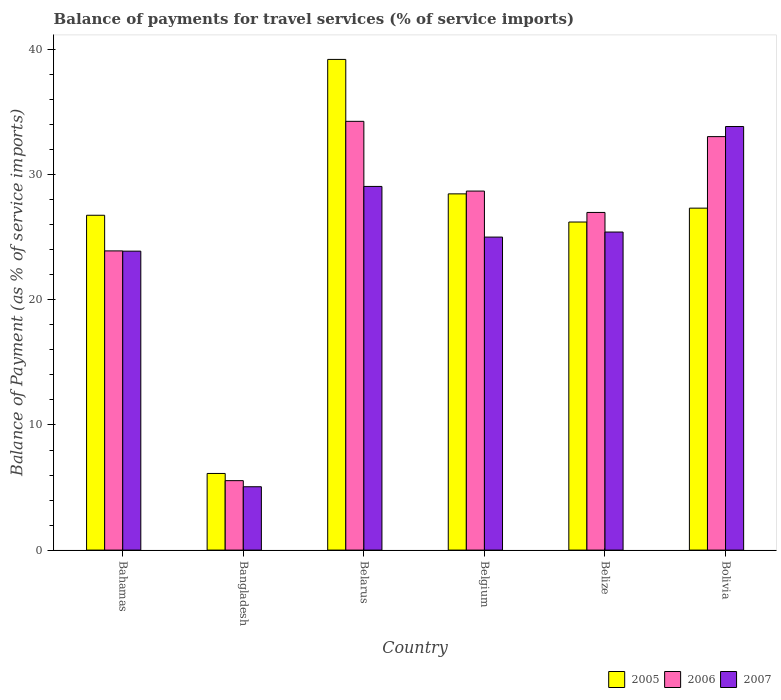How many different coloured bars are there?
Keep it short and to the point. 3. Are the number of bars per tick equal to the number of legend labels?
Give a very brief answer. Yes. How many bars are there on the 3rd tick from the left?
Keep it short and to the point. 3. How many bars are there on the 6th tick from the right?
Make the answer very short. 3. What is the label of the 5th group of bars from the left?
Make the answer very short. Belize. What is the balance of payments for travel services in 2006 in Bolivia?
Your response must be concise. 33.05. Across all countries, what is the maximum balance of payments for travel services in 2006?
Your answer should be compact. 34.27. Across all countries, what is the minimum balance of payments for travel services in 2007?
Give a very brief answer. 5.06. In which country was the balance of payments for travel services in 2005 maximum?
Ensure brevity in your answer.  Belarus. In which country was the balance of payments for travel services in 2006 minimum?
Give a very brief answer. Bangladesh. What is the total balance of payments for travel services in 2007 in the graph?
Offer a very short reply. 142.32. What is the difference between the balance of payments for travel services in 2006 in Belarus and that in Belgium?
Offer a very short reply. 5.57. What is the difference between the balance of payments for travel services in 2006 in Belize and the balance of payments for travel services in 2007 in Bangladesh?
Give a very brief answer. 21.92. What is the average balance of payments for travel services in 2007 per country?
Offer a terse response. 23.72. What is the difference between the balance of payments for travel services of/in 2007 and balance of payments for travel services of/in 2005 in Bolivia?
Give a very brief answer. 6.52. In how many countries, is the balance of payments for travel services in 2007 greater than 18 %?
Your answer should be compact. 5. What is the ratio of the balance of payments for travel services in 2007 in Bangladesh to that in Bolivia?
Provide a succinct answer. 0.15. Is the difference between the balance of payments for travel services in 2007 in Bahamas and Belgium greater than the difference between the balance of payments for travel services in 2005 in Bahamas and Belgium?
Keep it short and to the point. Yes. What is the difference between the highest and the second highest balance of payments for travel services in 2006?
Your response must be concise. -1.22. What is the difference between the highest and the lowest balance of payments for travel services in 2007?
Your answer should be very brief. 28.79. In how many countries, is the balance of payments for travel services in 2006 greater than the average balance of payments for travel services in 2006 taken over all countries?
Make the answer very short. 4. Is the sum of the balance of payments for travel services in 2007 in Belarus and Belgium greater than the maximum balance of payments for travel services in 2005 across all countries?
Keep it short and to the point. Yes. What does the 3rd bar from the right in Bahamas represents?
Provide a short and direct response. 2005. Is it the case that in every country, the sum of the balance of payments for travel services in 2006 and balance of payments for travel services in 2005 is greater than the balance of payments for travel services in 2007?
Offer a terse response. Yes. How many bars are there?
Your answer should be very brief. 18. How many countries are there in the graph?
Keep it short and to the point. 6. What is the difference between two consecutive major ticks on the Y-axis?
Your answer should be compact. 10. Are the values on the major ticks of Y-axis written in scientific E-notation?
Your answer should be compact. No. Does the graph contain any zero values?
Your response must be concise. No. Does the graph contain grids?
Provide a short and direct response. No. How many legend labels are there?
Provide a short and direct response. 3. How are the legend labels stacked?
Make the answer very short. Horizontal. What is the title of the graph?
Your answer should be very brief. Balance of payments for travel services (% of service imports). Does "1971" appear as one of the legend labels in the graph?
Provide a succinct answer. No. What is the label or title of the Y-axis?
Your answer should be very brief. Balance of Payment (as % of service imports). What is the Balance of Payment (as % of service imports) of 2005 in Bahamas?
Ensure brevity in your answer.  26.76. What is the Balance of Payment (as % of service imports) in 2006 in Bahamas?
Give a very brief answer. 23.92. What is the Balance of Payment (as % of service imports) of 2007 in Bahamas?
Make the answer very short. 23.89. What is the Balance of Payment (as % of service imports) in 2005 in Bangladesh?
Keep it short and to the point. 6.13. What is the Balance of Payment (as % of service imports) in 2006 in Bangladesh?
Make the answer very short. 5.55. What is the Balance of Payment (as % of service imports) in 2007 in Bangladesh?
Your answer should be very brief. 5.06. What is the Balance of Payment (as % of service imports) of 2005 in Belarus?
Make the answer very short. 39.22. What is the Balance of Payment (as % of service imports) of 2006 in Belarus?
Ensure brevity in your answer.  34.27. What is the Balance of Payment (as % of service imports) of 2007 in Belarus?
Provide a short and direct response. 29.07. What is the Balance of Payment (as % of service imports) in 2005 in Belgium?
Keep it short and to the point. 28.47. What is the Balance of Payment (as % of service imports) of 2006 in Belgium?
Offer a terse response. 28.7. What is the Balance of Payment (as % of service imports) in 2007 in Belgium?
Make the answer very short. 25.02. What is the Balance of Payment (as % of service imports) of 2005 in Belize?
Offer a very short reply. 26.22. What is the Balance of Payment (as % of service imports) of 2006 in Belize?
Offer a very short reply. 26.99. What is the Balance of Payment (as % of service imports) of 2007 in Belize?
Your answer should be very brief. 25.42. What is the Balance of Payment (as % of service imports) in 2005 in Bolivia?
Your response must be concise. 27.33. What is the Balance of Payment (as % of service imports) of 2006 in Bolivia?
Ensure brevity in your answer.  33.05. What is the Balance of Payment (as % of service imports) in 2007 in Bolivia?
Offer a terse response. 33.86. Across all countries, what is the maximum Balance of Payment (as % of service imports) in 2005?
Provide a succinct answer. 39.22. Across all countries, what is the maximum Balance of Payment (as % of service imports) in 2006?
Provide a succinct answer. 34.27. Across all countries, what is the maximum Balance of Payment (as % of service imports) in 2007?
Provide a succinct answer. 33.86. Across all countries, what is the minimum Balance of Payment (as % of service imports) of 2005?
Your answer should be very brief. 6.13. Across all countries, what is the minimum Balance of Payment (as % of service imports) of 2006?
Give a very brief answer. 5.55. Across all countries, what is the minimum Balance of Payment (as % of service imports) in 2007?
Make the answer very short. 5.06. What is the total Balance of Payment (as % of service imports) of 2005 in the graph?
Your response must be concise. 154.14. What is the total Balance of Payment (as % of service imports) of 2006 in the graph?
Give a very brief answer. 152.47. What is the total Balance of Payment (as % of service imports) in 2007 in the graph?
Offer a very short reply. 142.32. What is the difference between the Balance of Payment (as % of service imports) of 2005 in Bahamas and that in Bangladesh?
Provide a succinct answer. 20.64. What is the difference between the Balance of Payment (as % of service imports) in 2006 in Bahamas and that in Bangladesh?
Keep it short and to the point. 18.36. What is the difference between the Balance of Payment (as % of service imports) in 2007 in Bahamas and that in Bangladesh?
Your answer should be very brief. 18.83. What is the difference between the Balance of Payment (as % of service imports) of 2005 in Bahamas and that in Belarus?
Provide a succinct answer. -12.46. What is the difference between the Balance of Payment (as % of service imports) of 2006 in Bahamas and that in Belarus?
Make the answer very short. -10.36. What is the difference between the Balance of Payment (as % of service imports) of 2007 in Bahamas and that in Belarus?
Provide a succinct answer. -5.17. What is the difference between the Balance of Payment (as % of service imports) in 2005 in Bahamas and that in Belgium?
Give a very brief answer. -1.71. What is the difference between the Balance of Payment (as % of service imports) of 2006 in Bahamas and that in Belgium?
Make the answer very short. -4.78. What is the difference between the Balance of Payment (as % of service imports) in 2007 in Bahamas and that in Belgium?
Your answer should be compact. -1.12. What is the difference between the Balance of Payment (as % of service imports) of 2005 in Bahamas and that in Belize?
Keep it short and to the point. 0.54. What is the difference between the Balance of Payment (as % of service imports) in 2006 in Bahamas and that in Belize?
Offer a terse response. -3.07. What is the difference between the Balance of Payment (as % of service imports) of 2007 in Bahamas and that in Belize?
Provide a short and direct response. -1.53. What is the difference between the Balance of Payment (as % of service imports) in 2005 in Bahamas and that in Bolivia?
Your answer should be very brief. -0.57. What is the difference between the Balance of Payment (as % of service imports) of 2006 in Bahamas and that in Bolivia?
Your answer should be very brief. -9.13. What is the difference between the Balance of Payment (as % of service imports) of 2007 in Bahamas and that in Bolivia?
Your answer should be very brief. -9.96. What is the difference between the Balance of Payment (as % of service imports) in 2005 in Bangladesh and that in Belarus?
Keep it short and to the point. -33.09. What is the difference between the Balance of Payment (as % of service imports) in 2006 in Bangladesh and that in Belarus?
Your answer should be very brief. -28.72. What is the difference between the Balance of Payment (as % of service imports) of 2007 in Bangladesh and that in Belarus?
Give a very brief answer. -24. What is the difference between the Balance of Payment (as % of service imports) of 2005 in Bangladesh and that in Belgium?
Keep it short and to the point. -22.35. What is the difference between the Balance of Payment (as % of service imports) of 2006 in Bangladesh and that in Belgium?
Give a very brief answer. -23.15. What is the difference between the Balance of Payment (as % of service imports) of 2007 in Bangladesh and that in Belgium?
Give a very brief answer. -19.95. What is the difference between the Balance of Payment (as % of service imports) of 2005 in Bangladesh and that in Belize?
Your response must be concise. -20.1. What is the difference between the Balance of Payment (as % of service imports) in 2006 in Bangladesh and that in Belize?
Give a very brief answer. -21.44. What is the difference between the Balance of Payment (as % of service imports) of 2007 in Bangladesh and that in Belize?
Keep it short and to the point. -20.36. What is the difference between the Balance of Payment (as % of service imports) of 2005 in Bangladesh and that in Bolivia?
Your answer should be very brief. -21.21. What is the difference between the Balance of Payment (as % of service imports) of 2006 in Bangladesh and that in Bolivia?
Make the answer very short. -27.5. What is the difference between the Balance of Payment (as % of service imports) of 2007 in Bangladesh and that in Bolivia?
Give a very brief answer. -28.79. What is the difference between the Balance of Payment (as % of service imports) of 2005 in Belarus and that in Belgium?
Your response must be concise. 10.75. What is the difference between the Balance of Payment (as % of service imports) in 2006 in Belarus and that in Belgium?
Offer a very short reply. 5.57. What is the difference between the Balance of Payment (as % of service imports) in 2007 in Belarus and that in Belgium?
Offer a very short reply. 4.05. What is the difference between the Balance of Payment (as % of service imports) in 2005 in Belarus and that in Belize?
Your answer should be compact. 13. What is the difference between the Balance of Payment (as % of service imports) of 2006 in Belarus and that in Belize?
Give a very brief answer. 7.28. What is the difference between the Balance of Payment (as % of service imports) in 2007 in Belarus and that in Belize?
Provide a succinct answer. 3.65. What is the difference between the Balance of Payment (as % of service imports) in 2005 in Belarus and that in Bolivia?
Your answer should be compact. 11.89. What is the difference between the Balance of Payment (as % of service imports) of 2006 in Belarus and that in Bolivia?
Offer a terse response. 1.22. What is the difference between the Balance of Payment (as % of service imports) of 2007 in Belarus and that in Bolivia?
Give a very brief answer. -4.79. What is the difference between the Balance of Payment (as % of service imports) in 2005 in Belgium and that in Belize?
Your response must be concise. 2.25. What is the difference between the Balance of Payment (as % of service imports) of 2006 in Belgium and that in Belize?
Make the answer very short. 1.71. What is the difference between the Balance of Payment (as % of service imports) in 2007 in Belgium and that in Belize?
Make the answer very short. -0.4. What is the difference between the Balance of Payment (as % of service imports) of 2005 in Belgium and that in Bolivia?
Your response must be concise. 1.14. What is the difference between the Balance of Payment (as % of service imports) in 2006 in Belgium and that in Bolivia?
Your response must be concise. -4.35. What is the difference between the Balance of Payment (as % of service imports) of 2007 in Belgium and that in Bolivia?
Keep it short and to the point. -8.84. What is the difference between the Balance of Payment (as % of service imports) of 2005 in Belize and that in Bolivia?
Your answer should be very brief. -1.11. What is the difference between the Balance of Payment (as % of service imports) of 2006 in Belize and that in Bolivia?
Offer a terse response. -6.06. What is the difference between the Balance of Payment (as % of service imports) of 2007 in Belize and that in Bolivia?
Offer a very short reply. -8.43. What is the difference between the Balance of Payment (as % of service imports) of 2005 in Bahamas and the Balance of Payment (as % of service imports) of 2006 in Bangladesh?
Keep it short and to the point. 21.21. What is the difference between the Balance of Payment (as % of service imports) in 2005 in Bahamas and the Balance of Payment (as % of service imports) in 2007 in Bangladesh?
Your response must be concise. 21.7. What is the difference between the Balance of Payment (as % of service imports) of 2006 in Bahamas and the Balance of Payment (as % of service imports) of 2007 in Bangladesh?
Make the answer very short. 18.85. What is the difference between the Balance of Payment (as % of service imports) in 2005 in Bahamas and the Balance of Payment (as % of service imports) in 2006 in Belarus?
Your answer should be very brief. -7.51. What is the difference between the Balance of Payment (as % of service imports) in 2005 in Bahamas and the Balance of Payment (as % of service imports) in 2007 in Belarus?
Ensure brevity in your answer.  -2.3. What is the difference between the Balance of Payment (as % of service imports) of 2006 in Bahamas and the Balance of Payment (as % of service imports) of 2007 in Belarus?
Offer a very short reply. -5.15. What is the difference between the Balance of Payment (as % of service imports) of 2005 in Bahamas and the Balance of Payment (as % of service imports) of 2006 in Belgium?
Provide a short and direct response. -1.93. What is the difference between the Balance of Payment (as % of service imports) in 2005 in Bahamas and the Balance of Payment (as % of service imports) in 2007 in Belgium?
Provide a succinct answer. 1.75. What is the difference between the Balance of Payment (as % of service imports) in 2006 in Bahamas and the Balance of Payment (as % of service imports) in 2007 in Belgium?
Offer a very short reply. -1.1. What is the difference between the Balance of Payment (as % of service imports) in 2005 in Bahamas and the Balance of Payment (as % of service imports) in 2006 in Belize?
Keep it short and to the point. -0.22. What is the difference between the Balance of Payment (as % of service imports) of 2005 in Bahamas and the Balance of Payment (as % of service imports) of 2007 in Belize?
Ensure brevity in your answer.  1.34. What is the difference between the Balance of Payment (as % of service imports) in 2006 in Bahamas and the Balance of Payment (as % of service imports) in 2007 in Belize?
Offer a terse response. -1.51. What is the difference between the Balance of Payment (as % of service imports) in 2005 in Bahamas and the Balance of Payment (as % of service imports) in 2006 in Bolivia?
Offer a terse response. -6.28. What is the difference between the Balance of Payment (as % of service imports) in 2005 in Bahamas and the Balance of Payment (as % of service imports) in 2007 in Bolivia?
Give a very brief answer. -7.09. What is the difference between the Balance of Payment (as % of service imports) in 2006 in Bahamas and the Balance of Payment (as % of service imports) in 2007 in Bolivia?
Give a very brief answer. -9.94. What is the difference between the Balance of Payment (as % of service imports) in 2005 in Bangladesh and the Balance of Payment (as % of service imports) in 2006 in Belarus?
Provide a succinct answer. -28.14. What is the difference between the Balance of Payment (as % of service imports) in 2005 in Bangladesh and the Balance of Payment (as % of service imports) in 2007 in Belarus?
Give a very brief answer. -22.94. What is the difference between the Balance of Payment (as % of service imports) in 2006 in Bangladesh and the Balance of Payment (as % of service imports) in 2007 in Belarus?
Your answer should be compact. -23.52. What is the difference between the Balance of Payment (as % of service imports) in 2005 in Bangladesh and the Balance of Payment (as % of service imports) in 2006 in Belgium?
Keep it short and to the point. -22.57. What is the difference between the Balance of Payment (as % of service imports) of 2005 in Bangladesh and the Balance of Payment (as % of service imports) of 2007 in Belgium?
Provide a short and direct response. -18.89. What is the difference between the Balance of Payment (as % of service imports) in 2006 in Bangladesh and the Balance of Payment (as % of service imports) in 2007 in Belgium?
Your response must be concise. -19.47. What is the difference between the Balance of Payment (as % of service imports) of 2005 in Bangladesh and the Balance of Payment (as % of service imports) of 2006 in Belize?
Your answer should be compact. -20.86. What is the difference between the Balance of Payment (as % of service imports) in 2005 in Bangladesh and the Balance of Payment (as % of service imports) in 2007 in Belize?
Ensure brevity in your answer.  -19.3. What is the difference between the Balance of Payment (as % of service imports) in 2006 in Bangladesh and the Balance of Payment (as % of service imports) in 2007 in Belize?
Offer a very short reply. -19.87. What is the difference between the Balance of Payment (as % of service imports) in 2005 in Bangladesh and the Balance of Payment (as % of service imports) in 2006 in Bolivia?
Offer a very short reply. -26.92. What is the difference between the Balance of Payment (as % of service imports) of 2005 in Bangladesh and the Balance of Payment (as % of service imports) of 2007 in Bolivia?
Your response must be concise. -27.73. What is the difference between the Balance of Payment (as % of service imports) in 2006 in Bangladesh and the Balance of Payment (as % of service imports) in 2007 in Bolivia?
Ensure brevity in your answer.  -28.3. What is the difference between the Balance of Payment (as % of service imports) in 2005 in Belarus and the Balance of Payment (as % of service imports) in 2006 in Belgium?
Your answer should be very brief. 10.52. What is the difference between the Balance of Payment (as % of service imports) of 2005 in Belarus and the Balance of Payment (as % of service imports) of 2007 in Belgium?
Your answer should be very brief. 14.2. What is the difference between the Balance of Payment (as % of service imports) of 2006 in Belarus and the Balance of Payment (as % of service imports) of 2007 in Belgium?
Offer a terse response. 9.25. What is the difference between the Balance of Payment (as % of service imports) of 2005 in Belarus and the Balance of Payment (as % of service imports) of 2006 in Belize?
Offer a very short reply. 12.23. What is the difference between the Balance of Payment (as % of service imports) of 2005 in Belarus and the Balance of Payment (as % of service imports) of 2007 in Belize?
Your answer should be compact. 13.8. What is the difference between the Balance of Payment (as % of service imports) of 2006 in Belarus and the Balance of Payment (as % of service imports) of 2007 in Belize?
Your answer should be compact. 8.85. What is the difference between the Balance of Payment (as % of service imports) of 2005 in Belarus and the Balance of Payment (as % of service imports) of 2006 in Bolivia?
Give a very brief answer. 6.17. What is the difference between the Balance of Payment (as % of service imports) of 2005 in Belarus and the Balance of Payment (as % of service imports) of 2007 in Bolivia?
Offer a terse response. 5.36. What is the difference between the Balance of Payment (as % of service imports) of 2006 in Belarus and the Balance of Payment (as % of service imports) of 2007 in Bolivia?
Your answer should be very brief. 0.41. What is the difference between the Balance of Payment (as % of service imports) in 2005 in Belgium and the Balance of Payment (as % of service imports) in 2006 in Belize?
Ensure brevity in your answer.  1.49. What is the difference between the Balance of Payment (as % of service imports) of 2005 in Belgium and the Balance of Payment (as % of service imports) of 2007 in Belize?
Provide a short and direct response. 3.05. What is the difference between the Balance of Payment (as % of service imports) of 2006 in Belgium and the Balance of Payment (as % of service imports) of 2007 in Belize?
Your response must be concise. 3.27. What is the difference between the Balance of Payment (as % of service imports) of 2005 in Belgium and the Balance of Payment (as % of service imports) of 2006 in Bolivia?
Offer a terse response. -4.58. What is the difference between the Balance of Payment (as % of service imports) of 2005 in Belgium and the Balance of Payment (as % of service imports) of 2007 in Bolivia?
Your answer should be very brief. -5.38. What is the difference between the Balance of Payment (as % of service imports) in 2006 in Belgium and the Balance of Payment (as % of service imports) in 2007 in Bolivia?
Offer a terse response. -5.16. What is the difference between the Balance of Payment (as % of service imports) of 2005 in Belize and the Balance of Payment (as % of service imports) of 2006 in Bolivia?
Your answer should be compact. -6.83. What is the difference between the Balance of Payment (as % of service imports) of 2005 in Belize and the Balance of Payment (as % of service imports) of 2007 in Bolivia?
Offer a very short reply. -7.63. What is the difference between the Balance of Payment (as % of service imports) of 2006 in Belize and the Balance of Payment (as % of service imports) of 2007 in Bolivia?
Provide a succinct answer. -6.87. What is the average Balance of Payment (as % of service imports) in 2005 per country?
Your response must be concise. 25.69. What is the average Balance of Payment (as % of service imports) of 2006 per country?
Provide a short and direct response. 25.41. What is the average Balance of Payment (as % of service imports) in 2007 per country?
Ensure brevity in your answer.  23.72. What is the difference between the Balance of Payment (as % of service imports) in 2005 and Balance of Payment (as % of service imports) in 2006 in Bahamas?
Make the answer very short. 2.85. What is the difference between the Balance of Payment (as % of service imports) in 2005 and Balance of Payment (as % of service imports) in 2007 in Bahamas?
Provide a short and direct response. 2.87. What is the difference between the Balance of Payment (as % of service imports) of 2006 and Balance of Payment (as % of service imports) of 2007 in Bahamas?
Make the answer very short. 0.02. What is the difference between the Balance of Payment (as % of service imports) of 2005 and Balance of Payment (as % of service imports) of 2006 in Bangladesh?
Give a very brief answer. 0.57. What is the difference between the Balance of Payment (as % of service imports) of 2005 and Balance of Payment (as % of service imports) of 2007 in Bangladesh?
Your answer should be compact. 1.06. What is the difference between the Balance of Payment (as % of service imports) of 2006 and Balance of Payment (as % of service imports) of 2007 in Bangladesh?
Ensure brevity in your answer.  0.49. What is the difference between the Balance of Payment (as % of service imports) in 2005 and Balance of Payment (as % of service imports) in 2006 in Belarus?
Your answer should be very brief. 4.95. What is the difference between the Balance of Payment (as % of service imports) of 2005 and Balance of Payment (as % of service imports) of 2007 in Belarus?
Keep it short and to the point. 10.15. What is the difference between the Balance of Payment (as % of service imports) in 2006 and Balance of Payment (as % of service imports) in 2007 in Belarus?
Offer a very short reply. 5.2. What is the difference between the Balance of Payment (as % of service imports) in 2005 and Balance of Payment (as % of service imports) in 2006 in Belgium?
Provide a short and direct response. -0.22. What is the difference between the Balance of Payment (as % of service imports) of 2005 and Balance of Payment (as % of service imports) of 2007 in Belgium?
Give a very brief answer. 3.45. What is the difference between the Balance of Payment (as % of service imports) in 2006 and Balance of Payment (as % of service imports) in 2007 in Belgium?
Provide a succinct answer. 3.68. What is the difference between the Balance of Payment (as % of service imports) of 2005 and Balance of Payment (as % of service imports) of 2006 in Belize?
Ensure brevity in your answer.  -0.76. What is the difference between the Balance of Payment (as % of service imports) of 2005 and Balance of Payment (as % of service imports) of 2007 in Belize?
Offer a terse response. 0.8. What is the difference between the Balance of Payment (as % of service imports) in 2006 and Balance of Payment (as % of service imports) in 2007 in Belize?
Provide a succinct answer. 1.57. What is the difference between the Balance of Payment (as % of service imports) of 2005 and Balance of Payment (as % of service imports) of 2006 in Bolivia?
Your response must be concise. -5.72. What is the difference between the Balance of Payment (as % of service imports) in 2005 and Balance of Payment (as % of service imports) in 2007 in Bolivia?
Offer a terse response. -6.52. What is the difference between the Balance of Payment (as % of service imports) of 2006 and Balance of Payment (as % of service imports) of 2007 in Bolivia?
Your response must be concise. -0.81. What is the ratio of the Balance of Payment (as % of service imports) of 2005 in Bahamas to that in Bangladesh?
Keep it short and to the point. 4.37. What is the ratio of the Balance of Payment (as % of service imports) of 2006 in Bahamas to that in Bangladesh?
Ensure brevity in your answer.  4.31. What is the ratio of the Balance of Payment (as % of service imports) of 2007 in Bahamas to that in Bangladesh?
Your answer should be very brief. 4.72. What is the ratio of the Balance of Payment (as % of service imports) of 2005 in Bahamas to that in Belarus?
Offer a very short reply. 0.68. What is the ratio of the Balance of Payment (as % of service imports) of 2006 in Bahamas to that in Belarus?
Give a very brief answer. 0.7. What is the ratio of the Balance of Payment (as % of service imports) of 2007 in Bahamas to that in Belarus?
Provide a short and direct response. 0.82. What is the ratio of the Balance of Payment (as % of service imports) in 2005 in Bahamas to that in Belgium?
Provide a short and direct response. 0.94. What is the ratio of the Balance of Payment (as % of service imports) in 2006 in Bahamas to that in Belgium?
Offer a terse response. 0.83. What is the ratio of the Balance of Payment (as % of service imports) of 2007 in Bahamas to that in Belgium?
Give a very brief answer. 0.96. What is the ratio of the Balance of Payment (as % of service imports) in 2005 in Bahamas to that in Belize?
Offer a terse response. 1.02. What is the ratio of the Balance of Payment (as % of service imports) in 2006 in Bahamas to that in Belize?
Keep it short and to the point. 0.89. What is the ratio of the Balance of Payment (as % of service imports) of 2007 in Bahamas to that in Belize?
Make the answer very short. 0.94. What is the ratio of the Balance of Payment (as % of service imports) of 2005 in Bahamas to that in Bolivia?
Your answer should be very brief. 0.98. What is the ratio of the Balance of Payment (as % of service imports) of 2006 in Bahamas to that in Bolivia?
Make the answer very short. 0.72. What is the ratio of the Balance of Payment (as % of service imports) of 2007 in Bahamas to that in Bolivia?
Your answer should be very brief. 0.71. What is the ratio of the Balance of Payment (as % of service imports) of 2005 in Bangladesh to that in Belarus?
Your response must be concise. 0.16. What is the ratio of the Balance of Payment (as % of service imports) of 2006 in Bangladesh to that in Belarus?
Your answer should be very brief. 0.16. What is the ratio of the Balance of Payment (as % of service imports) in 2007 in Bangladesh to that in Belarus?
Offer a terse response. 0.17. What is the ratio of the Balance of Payment (as % of service imports) in 2005 in Bangladesh to that in Belgium?
Offer a terse response. 0.22. What is the ratio of the Balance of Payment (as % of service imports) in 2006 in Bangladesh to that in Belgium?
Ensure brevity in your answer.  0.19. What is the ratio of the Balance of Payment (as % of service imports) in 2007 in Bangladesh to that in Belgium?
Offer a very short reply. 0.2. What is the ratio of the Balance of Payment (as % of service imports) of 2005 in Bangladesh to that in Belize?
Provide a succinct answer. 0.23. What is the ratio of the Balance of Payment (as % of service imports) in 2006 in Bangladesh to that in Belize?
Provide a succinct answer. 0.21. What is the ratio of the Balance of Payment (as % of service imports) of 2007 in Bangladesh to that in Belize?
Provide a short and direct response. 0.2. What is the ratio of the Balance of Payment (as % of service imports) of 2005 in Bangladesh to that in Bolivia?
Your answer should be very brief. 0.22. What is the ratio of the Balance of Payment (as % of service imports) in 2006 in Bangladesh to that in Bolivia?
Your answer should be compact. 0.17. What is the ratio of the Balance of Payment (as % of service imports) in 2007 in Bangladesh to that in Bolivia?
Your answer should be very brief. 0.15. What is the ratio of the Balance of Payment (as % of service imports) in 2005 in Belarus to that in Belgium?
Your answer should be very brief. 1.38. What is the ratio of the Balance of Payment (as % of service imports) of 2006 in Belarus to that in Belgium?
Your answer should be very brief. 1.19. What is the ratio of the Balance of Payment (as % of service imports) of 2007 in Belarus to that in Belgium?
Provide a short and direct response. 1.16. What is the ratio of the Balance of Payment (as % of service imports) in 2005 in Belarus to that in Belize?
Provide a short and direct response. 1.5. What is the ratio of the Balance of Payment (as % of service imports) of 2006 in Belarus to that in Belize?
Ensure brevity in your answer.  1.27. What is the ratio of the Balance of Payment (as % of service imports) in 2007 in Belarus to that in Belize?
Keep it short and to the point. 1.14. What is the ratio of the Balance of Payment (as % of service imports) in 2005 in Belarus to that in Bolivia?
Your answer should be compact. 1.44. What is the ratio of the Balance of Payment (as % of service imports) of 2006 in Belarus to that in Bolivia?
Provide a short and direct response. 1.04. What is the ratio of the Balance of Payment (as % of service imports) of 2007 in Belarus to that in Bolivia?
Make the answer very short. 0.86. What is the ratio of the Balance of Payment (as % of service imports) of 2005 in Belgium to that in Belize?
Offer a terse response. 1.09. What is the ratio of the Balance of Payment (as % of service imports) of 2006 in Belgium to that in Belize?
Make the answer very short. 1.06. What is the ratio of the Balance of Payment (as % of service imports) in 2007 in Belgium to that in Belize?
Your answer should be very brief. 0.98. What is the ratio of the Balance of Payment (as % of service imports) in 2005 in Belgium to that in Bolivia?
Provide a succinct answer. 1.04. What is the ratio of the Balance of Payment (as % of service imports) of 2006 in Belgium to that in Bolivia?
Your response must be concise. 0.87. What is the ratio of the Balance of Payment (as % of service imports) in 2007 in Belgium to that in Bolivia?
Give a very brief answer. 0.74. What is the ratio of the Balance of Payment (as % of service imports) of 2005 in Belize to that in Bolivia?
Your answer should be very brief. 0.96. What is the ratio of the Balance of Payment (as % of service imports) of 2006 in Belize to that in Bolivia?
Provide a short and direct response. 0.82. What is the ratio of the Balance of Payment (as % of service imports) in 2007 in Belize to that in Bolivia?
Give a very brief answer. 0.75. What is the difference between the highest and the second highest Balance of Payment (as % of service imports) in 2005?
Make the answer very short. 10.75. What is the difference between the highest and the second highest Balance of Payment (as % of service imports) in 2006?
Your answer should be very brief. 1.22. What is the difference between the highest and the second highest Balance of Payment (as % of service imports) of 2007?
Offer a terse response. 4.79. What is the difference between the highest and the lowest Balance of Payment (as % of service imports) in 2005?
Give a very brief answer. 33.09. What is the difference between the highest and the lowest Balance of Payment (as % of service imports) of 2006?
Offer a terse response. 28.72. What is the difference between the highest and the lowest Balance of Payment (as % of service imports) of 2007?
Keep it short and to the point. 28.79. 